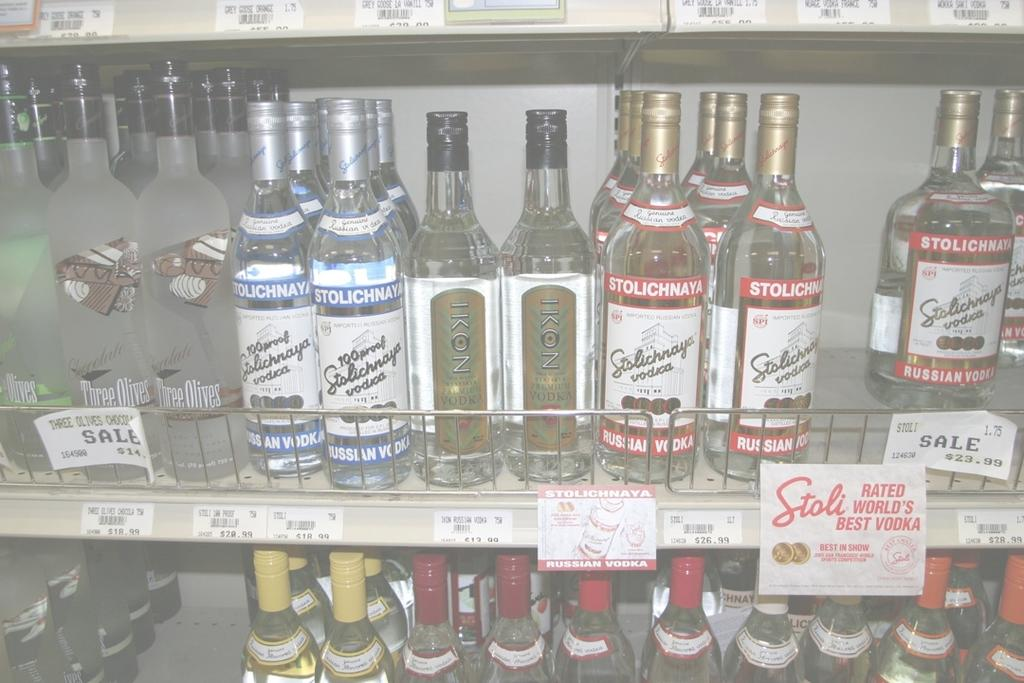What objects are present in large quantities in the image? There are many bottles in the image. Where are the bottles located? The bottles are on a shelf. What type of knot is used to secure the bottles on the shelf? There is no knot present in the image, as the bottles are simply placed on the shelf. 